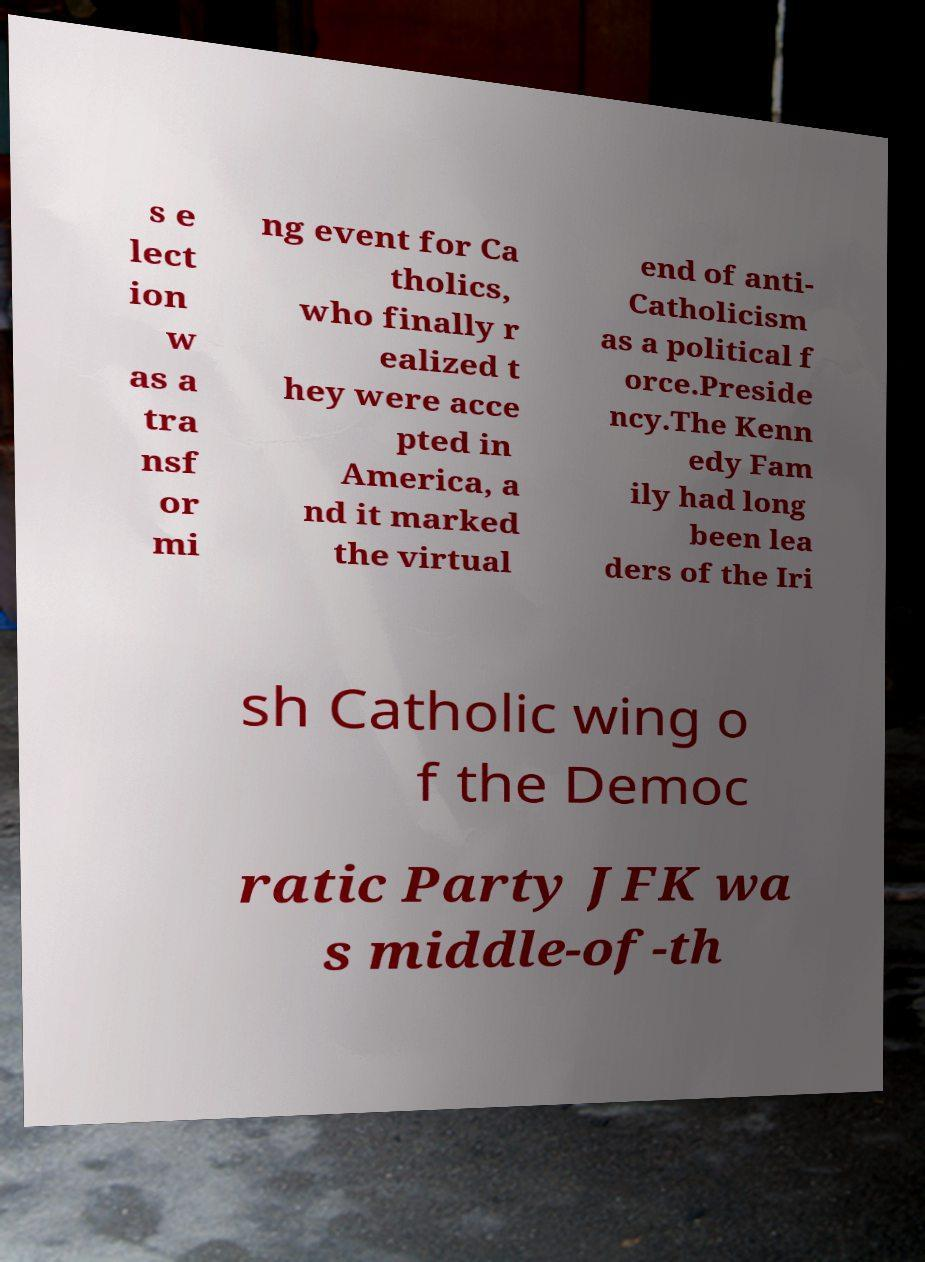Could you extract and type out the text from this image? s e lect ion w as a tra nsf or mi ng event for Ca tholics, who finally r ealized t hey were acce pted in America, a nd it marked the virtual end of anti- Catholicism as a political f orce.Preside ncy.The Kenn edy Fam ily had long been lea ders of the Iri sh Catholic wing o f the Democ ratic Party JFK wa s middle-of-th 